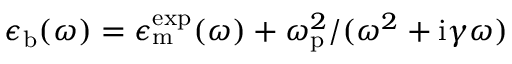<formula> <loc_0><loc_0><loc_500><loc_500>\epsilon _ { b } ( \omega ) = \epsilon _ { m } ^ { e x p } ( \omega ) + \omega _ { p } ^ { 2 } / ( \omega ^ { 2 } + i \gamma \omega )</formula> 